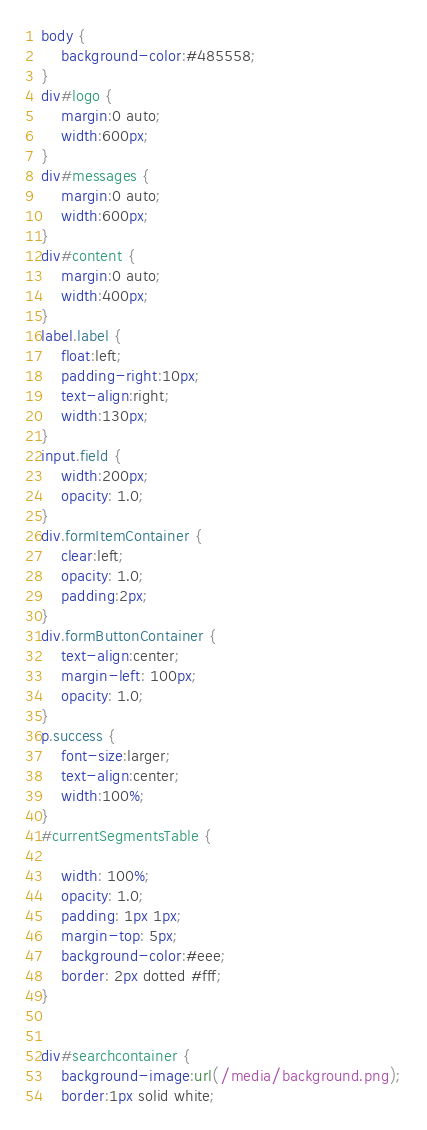Convert code to text. <code><loc_0><loc_0><loc_500><loc_500><_CSS_>body {
    background-color:#485558;
}
div#logo {
    margin:0 auto;
    width:600px;
}
div#messages {
    margin:0 auto;
    width:600px;
}
div#content {
    margin:0 auto;
    width:400px;
}
label.label {
    float:left;
    padding-right:10px;
    text-align:right;
    width:130px;
}
input.field {
    width:200px;
    opacity: 1.0;
}
div.formItemContainer {
    clear:left;
    opacity: 1.0;
    padding:2px;
}
div.formButtonContainer {
    text-align:center;
    margin-left: 100px;
    opacity: 1.0;
}
p.success {
    font-size:larger;
    text-align:center;
    width:100%;
}
#currentSegmentsTable {

    width: 100%;
    opacity: 1.0;
    padding: 1px 1px;
    margin-top: 5px;
    background-color:#eee;
    border: 2px dotted #fff;
}


div#searchcontainer {
    background-image:url(/media/background.png);
    border:1px solid white;</code> 